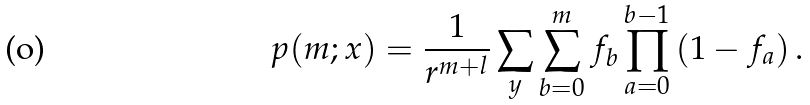Convert formula to latex. <formula><loc_0><loc_0><loc_500><loc_500>p ( m ; { x } ) = \frac { 1 } { r ^ { m + l } } \sum _ { y } \sum _ { b = 0 } ^ { m } f _ { b } \prod _ { a = 0 } ^ { b - 1 } \left ( 1 - f _ { a } \right ) .</formula> 